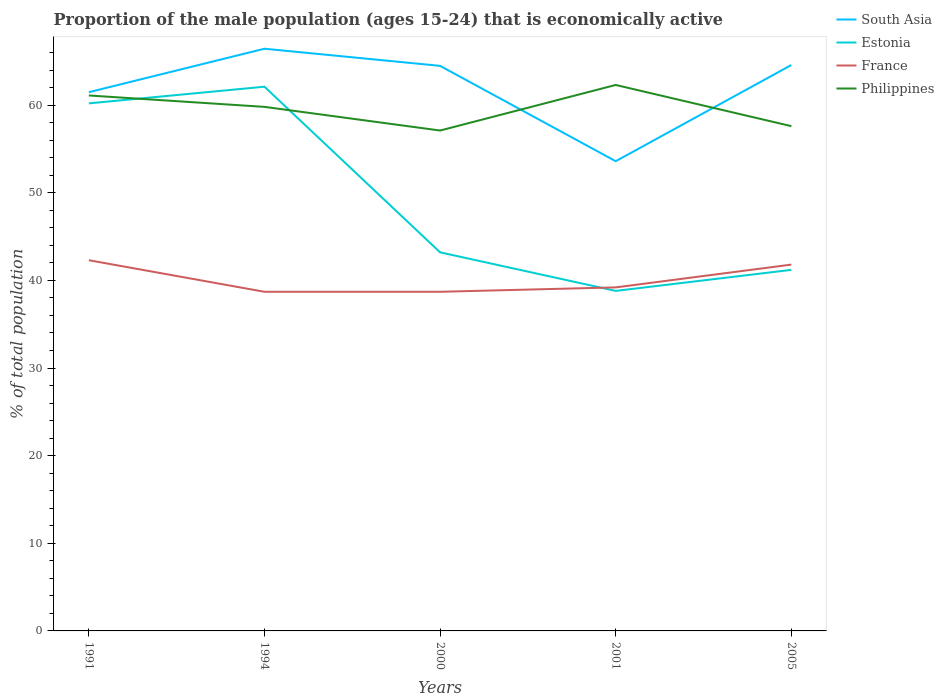Does the line corresponding to France intersect with the line corresponding to Estonia?
Your answer should be very brief. Yes. Across all years, what is the maximum proportion of the male population that is economically active in Estonia?
Your answer should be compact. 38.8. What is the difference between the highest and the second highest proportion of the male population that is economically active in France?
Your answer should be compact. 3.6. Is the proportion of the male population that is economically active in Estonia strictly greater than the proportion of the male population that is economically active in South Asia over the years?
Give a very brief answer. Yes. How many lines are there?
Provide a succinct answer. 4. How many years are there in the graph?
Give a very brief answer. 5. What is the difference between two consecutive major ticks on the Y-axis?
Ensure brevity in your answer.  10. Does the graph contain any zero values?
Offer a very short reply. No. Does the graph contain grids?
Your answer should be compact. No. How are the legend labels stacked?
Keep it short and to the point. Vertical. What is the title of the graph?
Ensure brevity in your answer.  Proportion of the male population (ages 15-24) that is economically active. Does "Middle East & North Africa (developing only)" appear as one of the legend labels in the graph?
Make the answer very short. No. What is the label or title of the Y-axis?
Make the answer very short. % of total population. What is the % of total population of South Asia in 1991?
Ensure brevity in your answer.  61.47. What is the % of total population in Estonia in 1991?
Provide a succinct answer. 60.2. What is the % of total population of France in 1991?
Give a very brief answer. 42.3. What is the % of total population of Philippines in 1991?
Provide a short and direct response. 61.1. What is the % of total population in South Asia in 1994?
Offer a very short reply. 66.43. What is the % of total population in Estonia in 1994?
Offer a terse response. 62.1. What is the % of total population of France in 1994?
Provide a short and direct response. 38.7. What is the % of total population of Philippines in 1994?
Your answer should be compact. 59.8. What is the % of total population in South Asia in 2000?
Ensure brevity in your answer.  64.48. What is the % of total population in Estonia in 2000?
Give a very brief answer. 43.2. What is the % of total population of France in 2000?
Your response must be concise. 38.7. What is the % of total population of Philippines in 2000?
Your answer should be very brief. 57.1. What is the % of total population in South Asia in 2001?
Your response must be concise. 53.6. What is the % of total population in Estonia in 2001?
Give a very brief answer. 38.8. What is the % of total population in France in 2001?
Provide a succinct answer. 39.2. What is the % of total population in Philippines in 2001?
Your answer should be very brief. 62.3. What is the % of total population of South Asia in 2005?
Give a very brief answer. 64.57. What is the % of total population of Estonia in 2005?
Your answer should be compact. 41.2. What is the % of total population of France in 2005?
Give a very brief answer. 41.8. What is the % of total population of Philippines in 2005?
Offer a very short reply. 57.6. Across all years, what is the maximum % of total population of South Asia?
Offer a terse response. 66.43. Across all years, what is the maximum % of total population of Estonia?
Make the answer very short. 62.1. Across all years, what is the maximum % of total population in France?
Ensure brevity in your answer.  42.3. Across all years, what is the maximum % of total population in Philippines?
Make the answer very short. 62.3. Across all years, what is the minimum % of total population in South Asia?
Your response must be concise. 53.6. Across all years, what is the minimum % of total population in Estonia?
Offer a very short reply. 38.8. Across all years, what is the minimum % of total population of France?
Your answer should be compact. 38.7. Across all years, what is the minimum % of total population in Philippines?
Keep it short and to the point. 57.1. What is the total % of total population in South Asia in the graph?
Offer a terse response. 310.56. What is the total % of total population in Estonia in the graph?
Provide a succinct answer. 245.5. What is the total % of total population in France in the graph?
Your response must be concise. 200.7. What is the total % of total population of Philippines in the graph?
Offer a terse response. 297.9. What is the difference between the % of total population of South Asia in 1991 and that in 1994?
Ensure brevity in your answer.  -4.96. What is the difference between the % of total population of Estonia in 1991 and that in 1994?
Give a very brief answer. -1.9. What is the difference between the % of total population of Philippines in 1991 and that in 1994?
Offer a very short reply. 1.3. What is the difference between the % of total population of South Asia in 1991 and that in 2000?
Your response must be concise. -3.01. What is the difference between the % of total population of South Asia in 1991 and that in 2001?
Provide a succinct answer. 7.87. What is the difference between the % of total population of Estonia in 1991 and that in 2001?
Ensure brevity in your answer.  21.4. What is the difference between the % of total population in Philippines in 1991 and that in 2001?
Your answer should be compact. -1.2. What is the difference between the % of total population in South Asia in 1991 and that in 2005?
Offer a very short reply. -3.1. What is the difference between the % of total population in Estonia in 1991 and that in 2005?
Provide a succinct answer. 19. What is the difference between the % of total population in South Asia in 1994 and that in 2000?
Your answer should be very brief. 1.95. What is the difference between the % of total population in France in 1994 and that in 2000?
Make the answer very short. 0. What is the difference between the % of total population in South Asia in 1994 and that in 2001?
Provide a short and direct response. 12.83. What is the difference between the % of total population of Estonia in 1994 and that in 2001?
Ensure brevity in your answer.  23.3. What is the difference between the % of total population of South Asia in 1994 and that in 2005?
Provide a short and direct response. 1.86. What is the difference between the % of total population of Estonia in 1994 and that in 2005?
Offer a very short reply. 20.9. What is the difference between the % of total population in South Asia in 2000 and that in 2001?
Your response must be concise. 10.88. What is the difference between the % of total population in South Asia in 2000 and that in 2005?
Provide a short and direct response. -0.09. What is the difference between the % of total population in Estonia in 2000 and that in 2005?
Make the answer very short. 2. What is the difference between the % of total population of France in 2000 and that in 2005?
Make the answer very short. -3.1. What is the difference between the % of total population in South Asia in 2001 and that in 2005?
Make the answer very short. -10.97. What is the difference between the % of total population of Estonia in 2001 and that in 2005?
Make the answer very short. -2.4. What is the difference between the % of total population of Philippines in 2001 and that in 2005?
Keep it short and to the point. 4.7. What is the difference between the % of total population in South Asia in 1991 and the % of total population in Estonia in 1994?
Your answer should be very brief. -0.63. What is the difference between the % of total population in South Asia in 1991 and the % of total population in France in 1994?
Give a very brief answer. 22.77. What is the difference between the % of total population in South Asia in 1991 and the % of total population in Philippines in 1994?
Keep it short and to the point. 1.67. What is the difference between the % of total population in Estonia in 1991 and the % of total population in Philippines in 1994?
Give a very brief answer. 0.4. What is the difference between the % of total population in France in 1991 and the % of total population in Philippines in 1994?
Offer a terse response. -17.5. What is the difference between the % of total population in South Asia in 1991 and the % of total population in Estonia in 2000?
Your answer should be compact. 18.27. What is the difference between the % of total population in South Asia in 1991 and the % of total population in France in 2000?
Offer a terse response. 22.77. What is the difference between the % of total population of South Asia in 1991 and the % of total population of Philippines in 2000?
Keep it short and to the point. 4.37. What is the difference between the % of total population in Estonia in 1991 and the % of total population in France in 2000?
Keep it short and to the point. 21.5. What is the difference between the % of total population in France in 1991 and the % of total population in Philippines in 2000?
Provide a succinct answer. -14.8. What is the difference between the % of total population in South Asia in 1991 and the % of total population in Estonia in 2001?
Ensure brevity in your answer.  22.67. What is the difference between the % of total population of South Asia in 1991 and the % of total population of France in 2001?
Offer a very short reply. 22.27. What is the difference between the % of total population of South Asia in 1991 and the % of total population of Philippines in 2001?
Give a very brief answer. -0.83. What is the difference between the % of total population of South Asia in 1991 and the % of total population of Estonia in 2005?
Ensure brevity in your answer.  20.27. What is the difference between the % of total population of South Asia in 1991 and the % of total population of France in 2005?
Provide a short and direct response. 19.67. What is the difference between the % of total population in South Asia in 1991 and the % of total population in Philippines in 2005?
Make the answer very short. 3.87. What is the difference between the % of total population of Estonia in 1991 and the % of total population of France in 2005?
Give a very brief answer. 18.4. What is the difference between the % of total population of France in 1991 and the % of total population of Philippines in 2005?
Make the answer very short. -15.3. What is the difference between the % of total population of South Asia in 1994 and the % of total population of Estonia in 2000?
Make the answer very short. 23.23. What is the difference between the % of total population in South Asia in 1994 and the % of total population in France in 2000?
Your answer should be compact. 27.73. What is the difference between the % of total population of South Asia in 1994 and the % of total population of Philippines in 2000?
Keep it short and to the point. 9.33. What is the difference between the % of total population in Estonia in 1994 and the % of total population in France in 2000?
Your response must be concise. 23.4. What is the difference between the % of total population of France in 1994 and the % of total population of Philippines in 2000?
Offer a terse response. -18.4. What is the difference between the % of total population of South Asia in 1994 and the % of total population of Estonia in 2001?
Provide a succinct answer. 27.63. What is the difference between the % of total population in South Asia in 1994 and the % of total population in France in 2001?
Give a very brief answer. 27.23. What is the difference between the % of total population of South Asia in 1994 and the % of total population of Philippines in 2001?
Your response must be concise. 4.13. What is the difference between the % of total population of Estonia in 1994 and the % of total population of France in 2001?
Your answer should be very brief. 22.9. What is the difference between the % of total population of Estonia in 1994 and the % of total population of Philippines in 2001?
Your answer should be compact. -0.2. What is the difference between the % of total population of France in 1994 and the % of total population of Philippines in 2001?
Offer a very short reply. -23.6. What is the difference between the % of total population in South Asia in 1994 and the % of total population in Estonia in 2005?
Ensure brevity in your answer.  25.23. What is the difference between the % of total population of South Asia in 1994 and the % of total population of France in 2005?
Offer a very short reply. 24.63. What is the difference between the % of total population in South Asia in 1994 and the % of total population in Philippines in 2005?
Offer a very short reply. 8.83. What is the difference between the % of total population in Estonia in 1994 and the % of total population in France in 2005?
Offer a terse response. 20.3. What is the difference between the % of total population of France in 1994 and the % of total population of Philippines in 2005?
Provide a succinct answer. -18.9. What is the difference between the % of total population in South Asia in 2000 and the % of total population in Estonia in 2001?
Offer a very short reply. 25.68. What is the difference between the % of total population of South Asia in 2000 and the % of total population of France in 2001?
Make the answer very short. 25.28. What is the difference between the % of total population in South Asia in 2000 and the % of total population in Philippines in 2001?
Offer a very short reply. 2.18. What is the difference between the % of total population in Estonia in 2000 and the % of total population in France in 2001?
Your answer should be very brief. 4. What is the difference between the % of total population in Estonia in 2000 and the % of total population in Philippines in 2001?
Your answer should be very brief. -19.1. What is the difference between the % of total population in France in 2000 and the % of total population in Philippines in 2001?
Your answer should be very brief. -23.6. What is the difference between the % of total population of South Asia in 2000 and the % of total population of Estonia in 2005?
Your response must be concise. 23.28. What is the difference between the % of total population in South Asia in 2000 and the % of total population in France in 2005?
Make the answer very short. 22.68. What is the difference between the % of total population of South Asia in 2000 and the % of total population of Philippines in 2005?
Offer a very short reply. 6.88. What is the difference between the % of total population of Estonia in 2000 and the % of total population of France in 2005?
Keep it short and to the point. 1.4. What is the difference between the % of total population of Estonia in 2000 and the % of total population of Philippines in 2005?
Provide a succinct answer. -14.4. What is the difference between the % of total population of France in 2000 and the % of total population of Philippines in 2005?
Offer a terse response. -18.9. What is the difference between the % of total population of South Asia in 2001 and the % of total population of France in 2005?
Offer a very short reply. 11.8. What is the difference between the % of total population of South Asia in 2001 and the % of total population of Philippines in 2005?
Your answer should be compact. -4. What is the difference between the % of total population of Estonia in 2001 and the % of total population of Philippines in 2005?
Offer a terse response. -18.8. What is the difference between the % of total population of France in 2001 and the % of total population of Philippines in 2005?
Offer a very short reply. -18.4. What is the average % of total population in South Asia per year?
Your answer should be very brief. 62.11. What is the average % of total population in Estonia per year?
Your response must be concise. 49.1. What is the average % of total population of France per year?
Your response must be concise. 40.14. What is the average % of total population in Philippines per year?
Provide a succinct answer. 59.58. In the year 1991, what is the difference between the % of total population in South Asia and % of total population in Estonia?
Provide a short and direct response. 1.27. In the year 1991, what is the difference between the % of total population in South Asia and % of total population in France?
Your answer should be compact. 19.17. In the year 1991, what is the difference between the % of total population in South Asia and % of total population in Philippines?
Your response must be concise. 0.37. In the year 1991, what is the difference between the % of total population of Estonia and % of total population of France?
Make the answer very short. 17.9. In the year 1991, what is the difference between the % of total population of France and % of total population of Philippines?
Ensure brevity in your answer.  -18.8. In the year 1994, what is the difference between the % of total population in South Asia and % of total population in Estonia?
Give a very brief answer. 4.33. In the year 1994, what is the difference between the % of total population in South Asia and % of total population in France?
Your response must be concise. 27.73. In the year 1994, what is the difference between the % of total population of South Asia and % of total population of Philippines?
Keep it short and to the point. 6.63. In the year 1994, what is the difference between the % of total population of Estonia and % of total population of France?
Give a very brief answer. 23.4. In the year 1994, what is the difference between the % of total population in Estonia and % of total population in Philippines?
Your answer should be compact. 2.3. In the year 1994, what is the difference between the % of total population in France and % of total population in Philippines?
Your response must be concise. -21.1. In the year 2000, what is the difference between the % of total population of South Asia and % of total population of Estonia?
Offer a very short reply. 21.28. In the year 2000, what is the difference between the % of total population in South Asia and % of total population in France?
Provide a short and direct response. 25.78. In the year 2000, what is the difference between the % of total population in South Asia and % of total population in Philippines?
Provide a short and direct response. 7.38. In the year 2000, what is the difference between the % of total population of Estonia and % of total population of France?
Keep it short and to the point. 4.5. In the year 2000, what is the difference between the % of total population in Estonia and % of total population in Philippines?
Keep it short and to the point. -13.9. In the year 2000, what is the difference between the % of total population of France and % of total population of Philippines?
Give a very brief answer. -18.4. In the year 2001, what is the difference between the % of total population in South Asia and % of total population in France?
Offer a very short reply. 14.4. In the year 2001, what is the difference between the % of total population in South Asia and % of total population in Philippines?
Your answer should be very brief. -8.7. In the year 2001, what is the difference between the % of total population in Estonia and % of total population in France?
Ensure brevity in your answer.  -0.4. In the year 2001, what is the difference between the % of total population of Estonia and % of total population of Philippines?
Your answer should be very brief. -23.5. In the year 2001, what is the difference between the % of total population of France and % of total population of Philippines?
Your answer should be very brief. -23.1. In the year 2005, what is the difference between the % of total population in South Asia and % of total population in Estonia?
Offer a terse response. 23.37. In the year 2005, what is the difference between the % of total population in South Asia and % of total population in France?
Provide a short and direct response. 22.77. In the year 2005, what is the difference between the % of total population in South Asia and % of total population in Philippines?
Provide a short and direct response. 6.97. In the year 2005, what is the difference between the % of total population in Estonia and % of total population in Philippines?
Provide a short and direct response. -16.4. In the year 2005, what is the difference between the % of total population in France and % of total population in Philippines?
Give a very brief answer. -15.8. What is the ratio of the % of total population of South Asia in 1991 to that in 1994?
Provide a succinct answer. 0.93. What is the ratio of the % of total population in Estonia in 1991 to that in 1994?
Keep it short and to the point. 0.97. What is the ratio of the % of total population of France in 1991 to that in 1994?
Your answer should be compact. 1.09. What is the ratio of the % of total population of Philippines in 1991 to that in 1994?
Your answer should be compact. 1.02. What is the ratio of the % of total population of South Asia in 1991 to that in 2000?
Your response must be concise. 0.95. What is the ratio of the % of total population of Estonia in 1991 to that in 2000?
Your answer should be very brief. 1.39. What is the ratio of the % of total population of France in 1991 to that in 2000?
Your answer should be very brief. 1.09. What is the ratio of the % of total population in Philippines in 1991 to that in 2000?
Provide a succinct answer. 1.07. What is the ratio of the % of total population in South Asia in 1991 to that in 2001?
Offer a terse response. 1.15. What is the ratio of the % of total population of Estonia in 1991 to that in 2001?
Ensure brevity in your answer.  1.55. What is the ratio of the % of total population in France in 1991 to that in 2001?
Your answer should be very brief. 1.08. What is the ratio of the % of total population of Philippines in 1991 to that in 2001?
Give a very brief answer. 0.98. What is the ratio of the % of total population of Estonia in 1991 to that in 2005?
Make the answer very short. 1.46. What is the ratio of the % of total population of France in 1991 to that in 2005?
Provide a succinct answer. 1.01. What is the ratio of the % of total population in Philippines in 1991 to that in 2005?
Your response must be concise. 1.06. What is the ratio of the % of total population of South Asia in 1994 to that in 2000?
Provide a short and direct response. 1.03. What is the ratio of the % of total population in Estonia in 1994 to that in 2000?
Give a very brief answer. 1.44. What is the ratio of the % of total population in France in 1994 to that in 2000?
Offer a very short reply. 1. What is the ratio of the % of total population in Philippines in 1994 to that in 2000?
Provide a succinct answer. 1.05. What is the ratio of the % of total population of South Asia in 1994 to that in 2001?
Give a very brief answer. 1.24. What is the ratio of the % of total population in Estonia in 1994 to that in 2001?
Offer a terse response. 1.6. What is the ratio of the % of total population of France in 1994 to that in 2001?
Ensure brevity in your answer.  0.99. What is the ratio of the % of total population of Philippines in 1994 to that in 2001?
Provide a succinct answer. 0.96. What is the ratio of the % of total population of South Asia in 1994 to that in 2005?
Your answer should be compact. 1.03. What is the ratio of the % of total population in Estonia in 1994 to that in 2005?
Your answer should be very brief. 1.51. What is the ratio of the % of total population in France in 1994 to that in 2005?
Ensure brevity in your answer.  0.93. What is the ratio of the % of total population in Philippines in 1994 to that in 2005?
Your answer should be compact. 1.04. What is the ratio of the % of total population in South Asia in 2000 to that in 2001?
Ensure brevity in your answer.  1.2. What is the ratio of the % of total population of Estonia in 2000 to that in 2001?
Offer a terse response. 1.11. What is the ratio of the % of total population in France in 2000 to that in 2001?
Offer a very short reply. 0.99. What is the ratio of the % of total population of Philippines in 2000 to that in 2001?
Make the answer very short. 0.92. What is the ratio of the % of total population of South Asia in 2000 to that in 2005?
Offer a very short reply. 1. What is the ratio of the % of total population in Estonia in 2000 to that in 2005?
Provide a short and direct response. 1.05. What is the ratio of the % of total population in France in 2000 to that in 2005?
Offer a terse response. 0.93. What is the ratio of the % of total population of South Asia in 2001 to that in 2005?
Give a very brief answer. 0.83. What is the ratio of the % of total population of Estonia in 2001 to that in 2005?
Keep it short and to the point. 0.94. What is the ratio of the % of total population of France in 2001 to that in 2005?
Your answer should be very brief. 0.94. What is the ratio of the % of total population of Philippines in 2001 to that in 2005?
Provide a succinct answer. 1.08. What is the difference between the highest and the second highest % of total population of South Asia?
Give a very brief answer. 1.86. What is the difference between the highest and the second highest % of total population of Estonia?
Give a very brief answer. 1.9. What is the difference between the highest and the second highest % of total population in France?
Give a very brief answer. 0.5. What is the difference between the highest and the second highest % of total population in Philippines?
Provide a succinct answer. 1.2. What is the difference between the highest and the lowest % of total population in South Asia?
Your answer should be compact. 12.83. What is the difference between the highest and the lowest % of total population of Estonia?
Provide a succinct answer. 23.3. What is the difference between the highest and the lowest % of total population in France?
Offer a terse response. 3.6. What is the difference between the highest and the lowest % of total population of Philippines?
Make the answer very short. 5.2. 